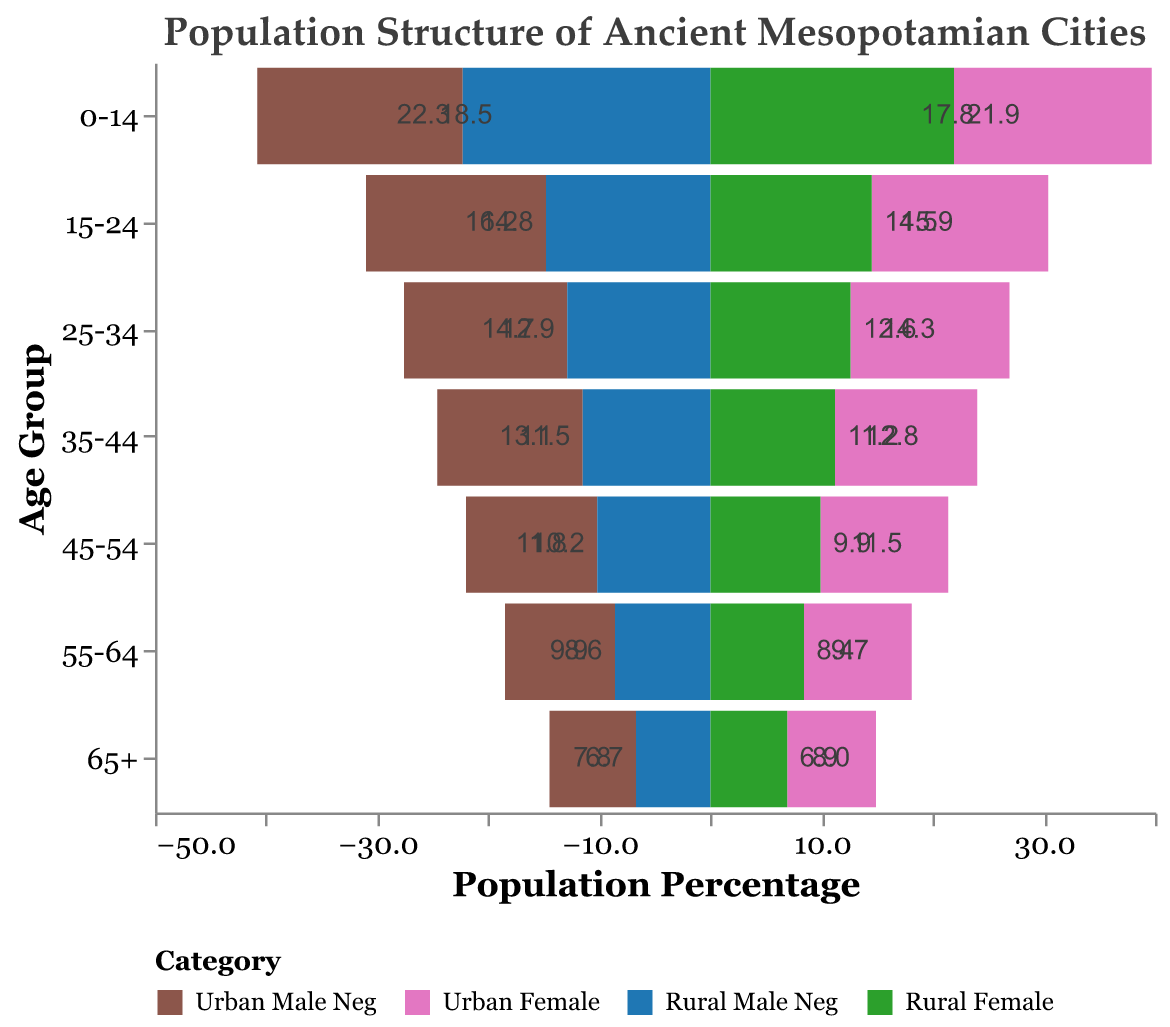How is the population distributed among different age groups for urban males and females? The urban male population is highest in the youngest age group (0-14) with 18.5%, and it decreases steadily with age, reaching 7.8% in the 65+ group. Similarly, urban females start at 17.8% in the 0-14 age group and decrease to 8.0% in the 65+ group
Answer: Younger age groups have higher percentages, and both decrease with age Which age group has the highest percentage of rural males? The 0-14 age group has the highest percentage of rural males at 22.3%
Answer: 0-14 age group What's the difference in the percentage of rural females in the 35-44 and 65+ age groups? For rural females, the 35-44 age group has 11.2%, and the 65+ age group has 6.9%. The difference is 11.2% - 6.9% = 4.3%
Answer: 4.3% In the 25-34 age group, which gender has a higher percentage in urban areas? The urban male percentage is 14.7%, and the urban female percentage is 14.3%. Therefore, urban males have a higher percentage
Answer: Urban males Between rural males and urban males, which group shows a larger decline from the 0-14 age group to the 65+ age group? Rural males start at 22.3% in 0-14 and drop to 6.7% in 65+, a decline of 22.3% - 6.7% = 15.6%. Urban males start at 18.5% and drop to 7.8%, a decline of 18.5% - 7.8% = 10.7%. Rural males show a larger decline
Answer: Rural males How does the population percentage for urban females in the 55-64 age group compare to rural males in the same age group? Urban females in 55-64 have a percentage of 9.7%, while rural males in the same age group have 8.6%. Urban females have a higher percentage
Answer: Urban females have a higher percentage 